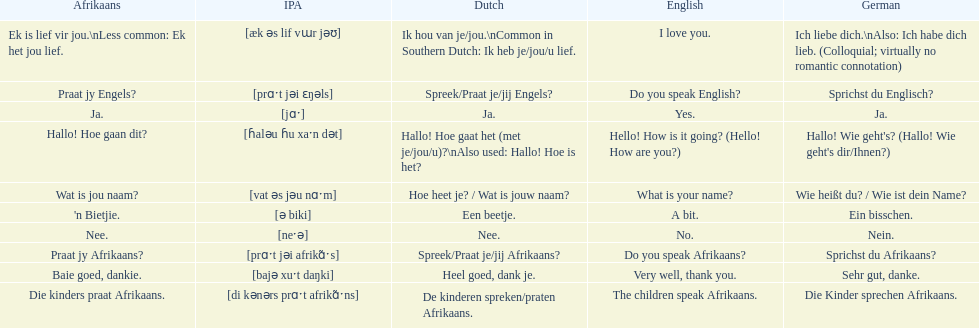How do you say 'yes' in afrikaans? Ja. 